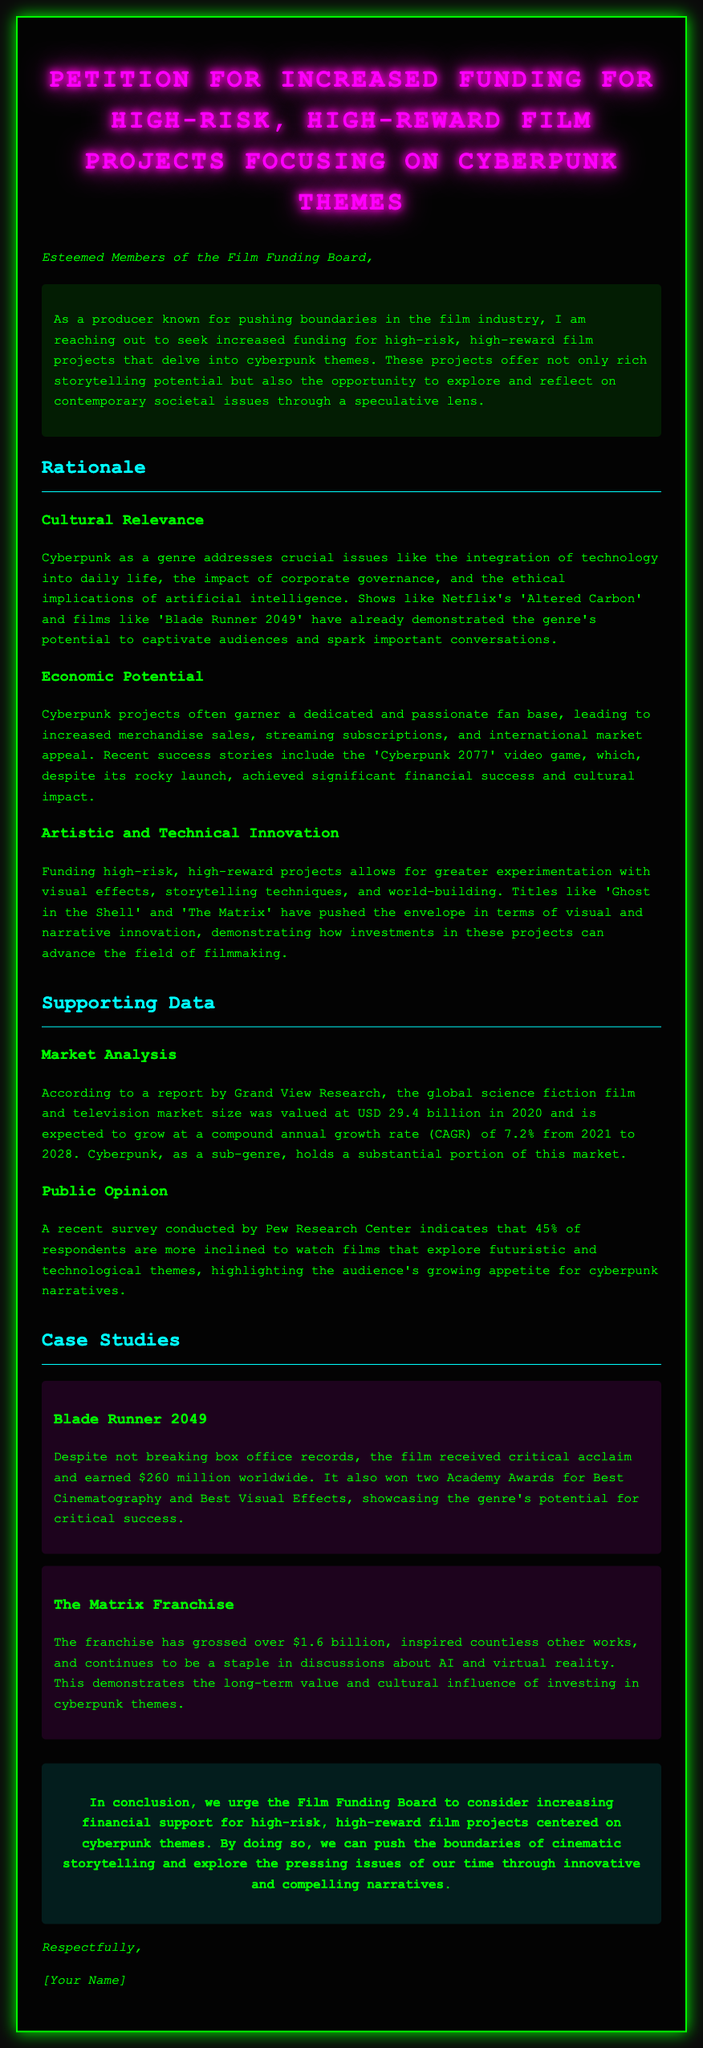What is the title of the petition? The title of the petition is clearly stated at the beginning of the document.
Answer: Petition for Increased Funding for High-Risk, High-Reward Film Projects Focusing on Cyberpunk Themes What year was the market size valued at USD 29.4 billion? The document provides a specific year for the market size valuation in the supporting data section.
Answer: 2020 What percentage of respondents prefer films exploring technological themes? The survey results included in the supporting data show this specific percentage.
Answer: 45% Which film received two Academy Awards according to the case study? The case studies section details films along with their accolades.
Answer: Blade Runner 2049 What is the expected compound annual growth rate (CAGR) from 2021 to 2028? The document contains information about market growth rates in the supporting data section.
Answer: 7.2% What is the main theme of the film projects being petitioned for funding? The document specifies the central theme being addressed in the petition.
Answer: Cyberpunk How many Academy Awards did Blade Runner 2049 win? The case study mentions the exact number of Academy Awards won by the film.
Answer: Two What genre does the petition focus on? The petition identifies the genre it is advocating for throughout the document.
Answer: Cyberpunk 